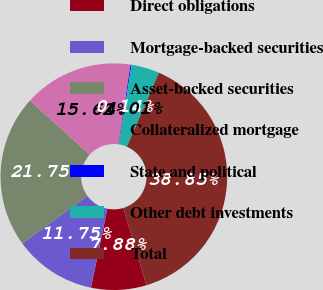<chart> <loc_0><loc_0><loc_500><loc_500><pie_chart><fcel>Direct obligations<fcel>Mortgage-backed securities<fcel>Asset-backed securities<fcel>Collateralized mortgage<fcel>State and political<fcel>Other debt investments<fcel>Total<nl><fcel>7.88%<fcel>11.75%<fcel>21.75%<fcel>15.62%<fcel>0.14%<fcel>4.01%<fcel>38.85%<nl></chart> 